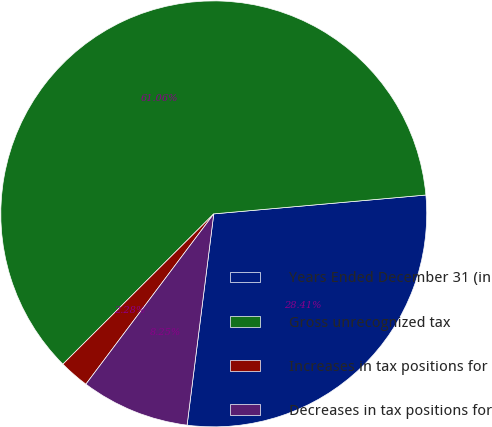Convert chart. <chart><loc_0><loc_0><loc_500><loc_500><pie_chart><fcel>Years Ended December 31 (in<fcel>Gross unrecognized tax<fcel>Increases in tax positions for<fcel>Decreases in tax positions for<nl><fcel>28.41%<fcel>61.06%<fcel>2.28%<fcel>8.25%<nl></chart> 